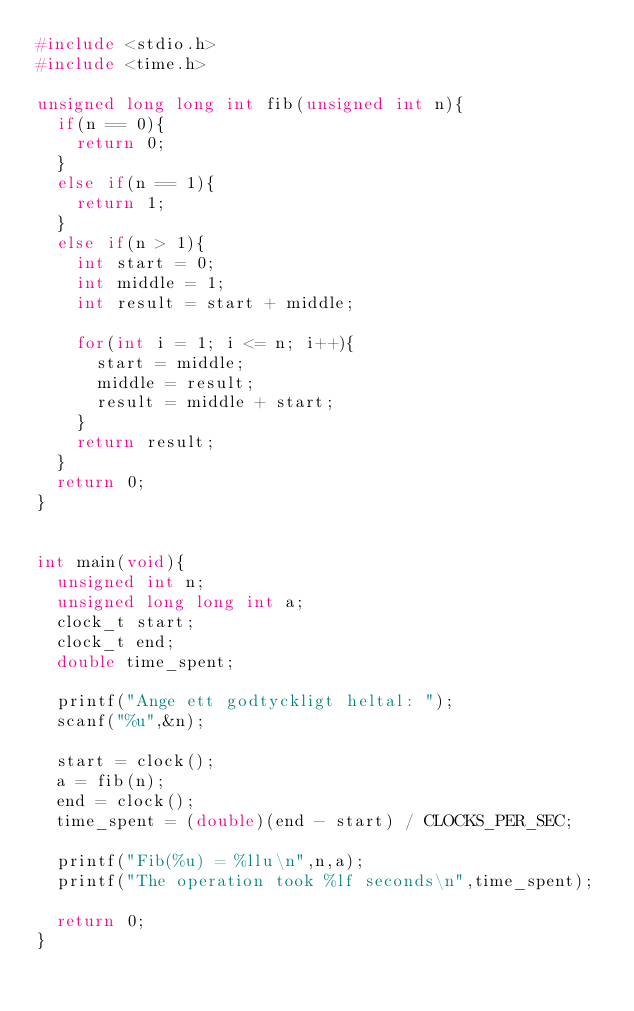Convert code to text. <code><loc_0><loc_0><loc_500><loc_500><_C_>#include <stdio.h>
#include <time.h>

unsigned long long int fib(unsigned int n){
	if(n == 0){
		return 0;
	}
	else if(n == 1){
		return 1;
	}
	else if(n > 1){
		int start = 0;
		int middle = 1;
		int result = start + middle;

		for(int i = 1; i <= n; i++){
			start = middle;
			middle = result;
			result = middle + start;
		}
		return result;
	}
	return 0;
}


int main(void){
	unsigned int n;
	unsigned long long int a;
	clock_t start;
	clock_t end;
	double time_spent;

	printf("Ange ett godtyckligt heltal: ");
	scanf("%u",&n);

	start = clock();
	a = fib(n);
	end = clock();
	time_spent = (double)(end - start) / CLOCKS_PER_SEC;

	printf("Fib(%u) = %llu\n",n,a);
	printf("The operation took %lf seconds\n",time_spent);

	return 0;
}
</code> 